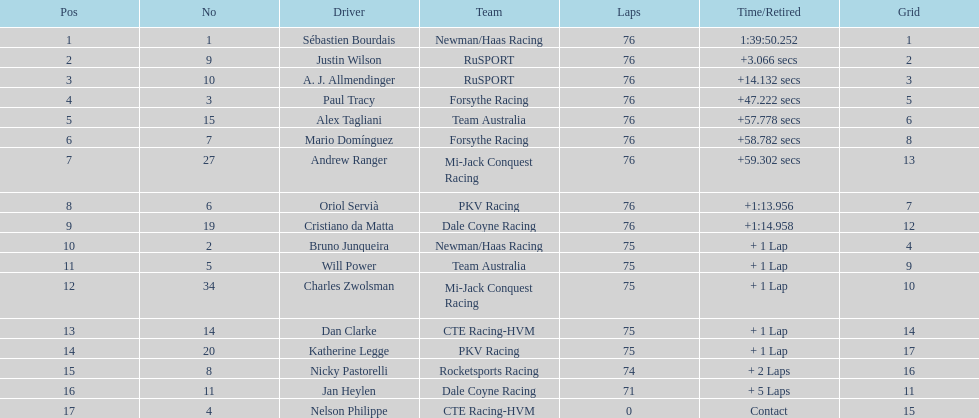How many points did charles zwolsman acquire? 9. Who else got 9 points? Dan Clarke. 